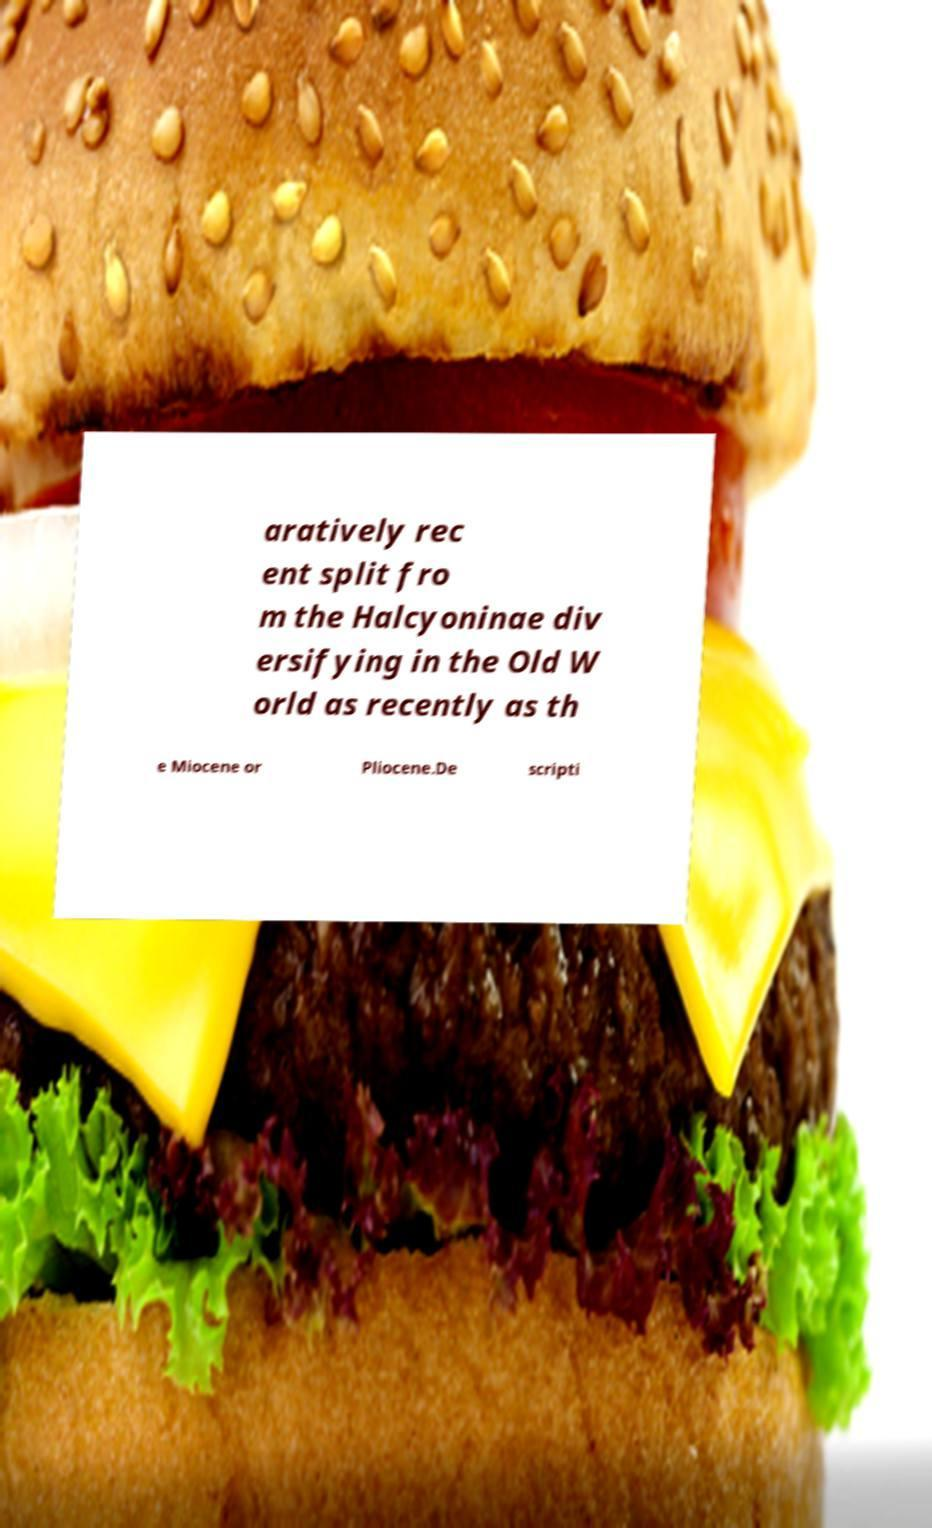Can you accurately transcribe the text from the provided image for me? aratively rec ent split fro m the Halcyoninae div ersifying in the Old W orld as recently as th e Miocene or Pliocene.De scripti 